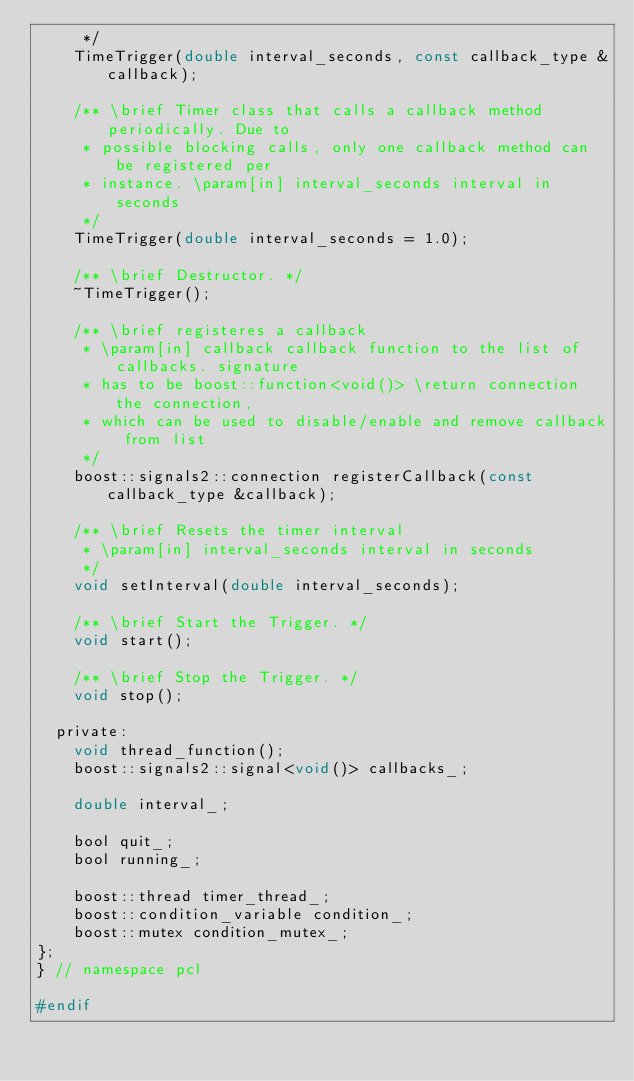Convert code to text. <code><loc_0><loc_0><loc_500><loc_500><_C_>     */
    TimeTrigger(double interval_seconds, const callback_type &callback);

    /** \brief Timer class that calls a callback method periodically. Due to
     * possible blocking calls, only one callback method can be registered per
     * instance. \param[in] interval_seconds interval in seconds
     */
    TimeTrigger(double interval_seconds = 1.0);

    /** \brief Destructor. */
    ~TimeTrigger();

    /** \brief registeres a callback
     * \param[in] callback callback function to the list of callbacks. signature
     * has to be boost::function<void()> \return connection the connection,
     * which can be used to disable/enable and remove callback from list
     */
    boost::signals2::connection registerCallback(const callback_type &callback);

    /** \brief Resets the timer interval
     * \param[in] interval_seconds interval in seconds
     */
    void setInterval(double interval_seconds);

    /** \brief Start the Trigger. */
    void start();

    /** \brief Stop the Trigger. */
    void stop();

  private:
    void thread_function();
    boost::signals2::signal<void()> callbacks_;

    double interval_;

    bool quit_;
    bool running_;

    boost::thread timer_thread_;
    boost::condition_variable condition_;
    boost::mutex condition_mutex_;
};
} // namespace pcl

#endif
</code> 